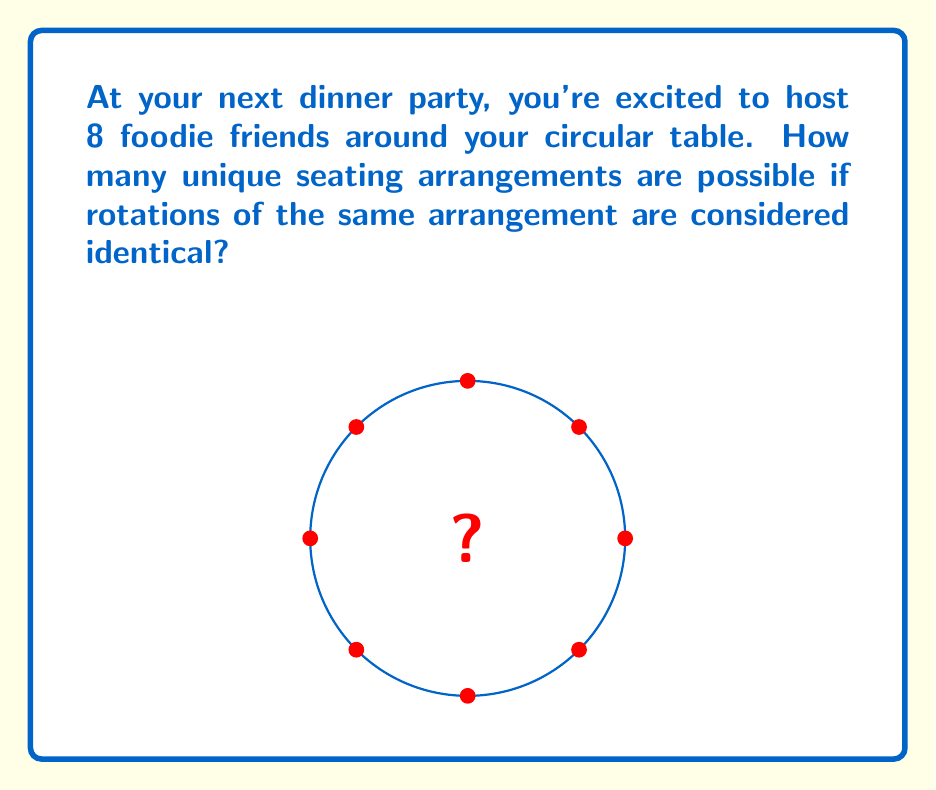Could you help me with this problem? Let's approach this step-by-step using ring theory:

1) First, recall that for a linear arrangement of $n$ people, there are $n!$ possible permutations.

2) However, we're dealing with a circular table where rotations are considered identical. This is where ring theory comes in.

3) In ring theory, we consider cyclic permutations. For a cyclic group of order $n$, there are $(n-1)!$ distinct cyclic permutations.

4) Why $(n-1)!$ and not $n!$? Because in a circular arrangement, we can fix one person's position and arrange the rest. This is equivalent to dividing the total number of linear permutations by $n$.

5) Mathematically, this is represented as:

   $$ \text{Number of unique circular arrangements} = \frac{n!}{n} = (n-1)! $$

6) In this case, we have 8 friends, so $n = 8$.

7) Therefore, the number of unique seating arrangements is:

   $$ (8-1)! = 7! = 7 \times 6 \times 5 \times 4 \times 3 \times 2 \times 1 = 5040 $$

This means there are 5040 different ways to arrange your 8 foodie friends around your circular dinner table.
Answer: 5040 